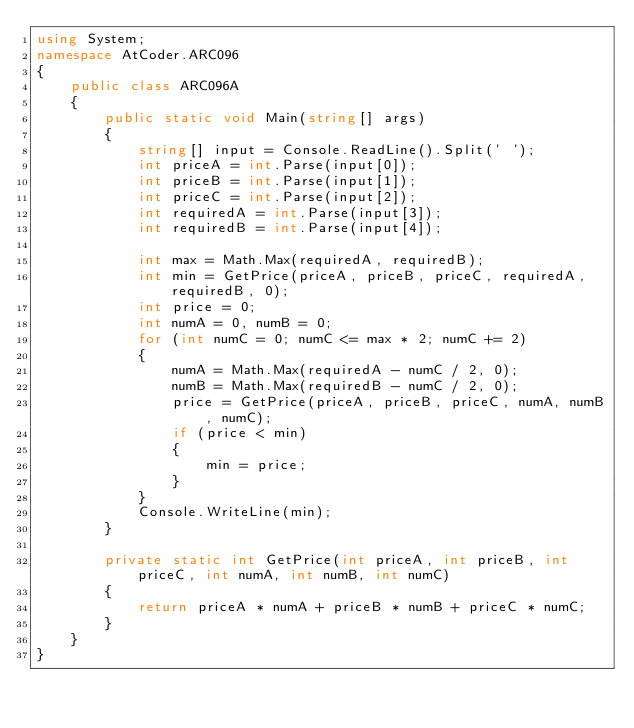Convert code to text. <code><loc_0><loc_0><loc_500><loc_500><_C#_>using System;
namespace AtCoder.ARC096
{
    public class ARC096A
    {
        public static void Main(string[] args)
        {
            string[] input = Console.ReadLine().Split(' ');
            int priceA = int.Parse(input[0]);
            int priceB = int.Parse(input[1]);
            int priceC = int.Parse(input[2]);
            int requiredA = int.Parse(input[3]);
            int requiredB = int.Parse(input[4]);

            int max = Math.Max(requiredA, requiredB);
            int min = GetPrice(priceA, priceB, priceC, requiredA, requiredB, 0);
            int price = 0;
            int numA = 0, numB = 0;
            for (int numC = 0; numC <= max * 2; numC += 2)
            {
                numA = Math.Max(requiredA - numC / 2, 0);
                numB = Math.Max(requiredB - numC / 2, 0);
                price = GetPrice(priceA, priceB, priceC, numA, numB, numC);
                if (price < min)
                {
                    min = price;
                }
            }
            Console.WriteLine(min);
        }

        private static int GetPrice(int priceA, int priceB, int priceC, int numA, int numB, int numC)
        {
            return priceA * numA + priceB * numB + priceC * numC;
        }
    }
}</code> 